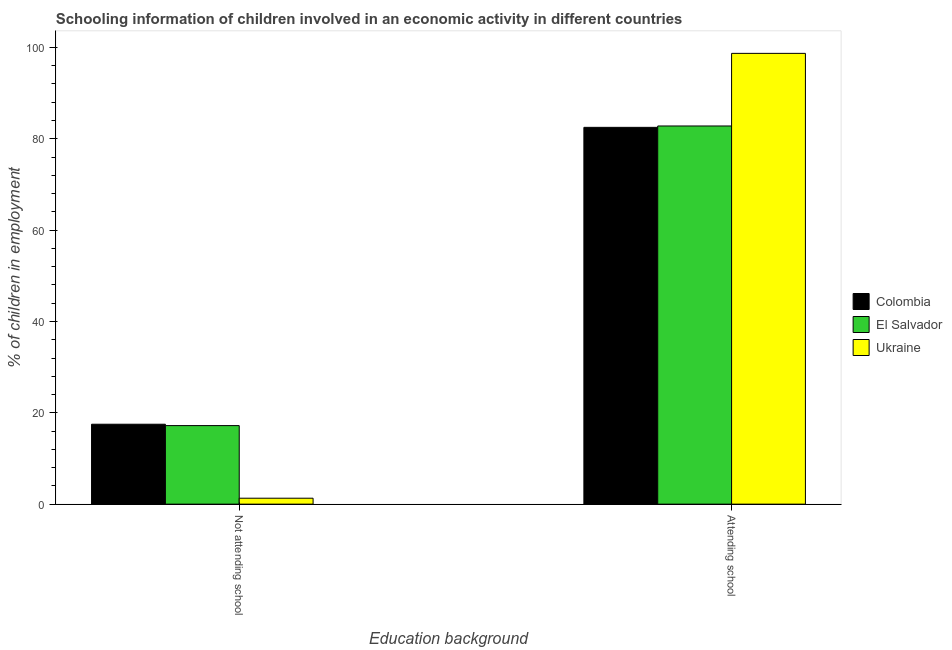How many bars are there on the 2nd tick from the left?
Keep it short and to the point. 3. How many bars are there on the 1st tick from the right?
Your response must be concise. 3. What is the label of the 1st group of bars from the left?
Provide a succinct answer. Not attending school. Across all countries, what is the maximum percentage of employed children who are attending school?
Ensure brevity in your answer.  98.7. In which country was the percentage of employed children who are attending school maximum?
Give a very brief answer. Ukraine. In which country was the percentage of employed children who are not attending school minimum?
Make the answer very short. Ukraine. What is the total percentage of employed children who are attending school in the graph?
Your answer should be very brief. 264. What is the difference between the percentage of employed children who are not attending school in Ukraine and that in Colombia?
Ensure brevity in your answer.  -16.2. What is the difference between the percentage of employed children who are not attending school in El Salvador and the percentage of employed children who are attending school in Colombia?
Make the answer very short. -65.3. What is the average percentage of employed children who are not attending school per country?
Provide a short and direct response. 12. What is the difference between the percentage of employed children who are not attending school and percentage of employed children who are attending school in Colombia?
Ensure brevity in your answer.  -65. What is the ratio of the percentage of employed children who are not attending school in Ukraine to that in Colombia?
Your answer should be very brief. 0.07. In how many countries, is the percentage of employed children who are attending school greater than the average percentage of employed children who are attending school taken over all countries?
Provide a short and direct response. 1. What does the 1st bar from the left in Attending school represents?
Provide a succinct answer. Colombia. What does the 1st bar from the right in Not attending school represents?
Provide a succinct answer. Ukraine. Are all the bars in the graph horizontal?
Ensure brevity in your answer.  No. What is the difference between two consecutive major ticks on the Y-axis?
Offer a very short reply. 20. Are the values on the major ticks of Y-axis written in scientific E-notation?
Give a very brief answer. No. What is the title of the graph?
Provide a succinct answer. Schooling information of children involved in an economic activity in different countries. Does "Gambia, The" appear as one of the legend labels in the graph?
Your answer should be very brief. No. What is the label or title of the X-axis?
Provide a short and direct response. Education background. What is the label or title of the Y-axis?
Your response must be concise. % of children in employment. What is the % of children in employment in El Salvador in Not attending school?
Your response must be concise. 17.2. What is the % of children in employment of Colombia in Attending school?
Your answer should be very brief. 82.5. What is the % of children in employment of El Salvador in Attending school?
Provide a succinct answer. 82.8. What is the % of children in employment in Ukraine in Attending school?
Your response must be concise. 98.7. Across all Education background, what is the maximum % of children in employment in Colombia?
Offer a very short reply. 82.5. Across all Education background, what is the maximum % of children in employment of El Salvador?
Offer a terse response. 82.8. Across all Education background, what is the maximum % of children in employment in Ukraine?
Ensure brevity in your answer.  98.7. Across all Education background, what is the minimum % of children in employment of Colombia?
Provide a succinct answer. 17.5. Across all Education background, what is the minimum % of children in employment of Ukraine?
Give a very brief answer. 1.3. What is the total % of children in employment in El Salvador in the graph?
Provide a succinct answer. 100. What is the total % of children in employment of Ukraine in the graph?
Keep it short and to the point. 100. What is the difference between the % of children in employment in Colombia in Not attending school and that in Attending school?
Your response must be concise. -65. What is the difference between the % of children in employment of El Salvador in Not attending school and that in Attending school?
Offer a terse response. -65.6. What is the difference between the % of children in employment of Ukraine in Not attending school and that in Attending school?
Give a very brief answer. -97.4. What is the difference between the % of children in employment in Colombia in Not attending school and the % of children in employment in El Salvador in Attending school?
Offer a very short reply. -65.3. What is the difference between the % of children in employment of Colombia in Not attending school and the % of children in employment of Ukraine in Attending school?
Offer a terse response. -81.2. What is the difference between the % of children in employment of El Salvador in Not attending school and the % of children in employment of Ukraine in Attending school?
Make the answer very short. -81.5. What is the average % of children in employment of Colombia per Education background?
Give a very brief answer. 50. What is the difference between the % of children in employment of Colombia and % of children in employment of Ukraine in Not attending school?
Provide a short and direct response. 16.2. What is the difference between the % of children in employment of Colombia and % of children in employment of El Salvador in Attending school?
Give a very brief answer. -0.3. What is the difference between the % of children in employment in Colombia and % of children in employment in Ukraine in Attending school?
Ensure brevity in your answer.  -16.2. What is the difference between the % of children in employment in El Salvador and % of children in employment in Ukraine in Attending school?
Keep it short and to the point. -15.9. What is the ratio of the % of children in employment of Colombia in Not attending school to that in Attending school?
Offer a very short reply. 0.21. What is the ratio of the % of children in employment of El Salvador in Not attending school to that in Attending school?
Ensure brevity in your answer.  0.21. What is the ratio of the % of children in employment of Ukraine in Not attending school to that in Attending school?
Your answer should be very brief. 0.01. What is the difference between the highest and the second highest % of children in employment of El Salvador?
Offer a terse response. 65.6. What is the difference between the highest and the second highest % of children in employment of Ukraine?
Your response must be concise. 97.4. What is the difference between the highest and the lowest % of children in employment in El Salvador?
Provide a short and direct response. 65.6. What is the difference between the highest and the lowest % of children in employment of Ukraine?
Keep it short and to the point. 97.4. 